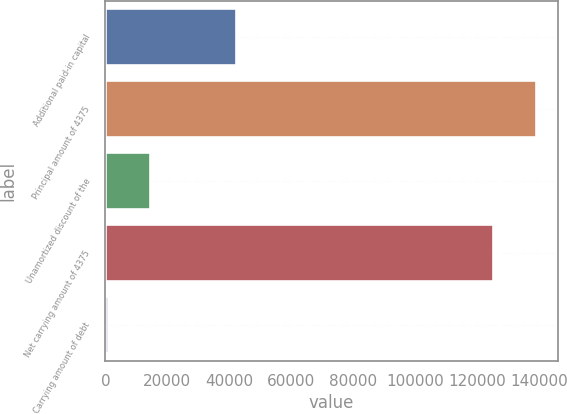Convert chart. <chart><loc_0><loc_0><loc_500><loc_500><bar_chart><fcel>Additional paid-in capital<fcel>Principal amount of 4375<fcel>Unamortized discount of the<fcel>Net carrying amount of 4375<fcel>Carrying amount of debt<nl><fcel>42018<fcel>138901<fcel>14517.3<fcel>125181<fcel>797<nl></chart> 